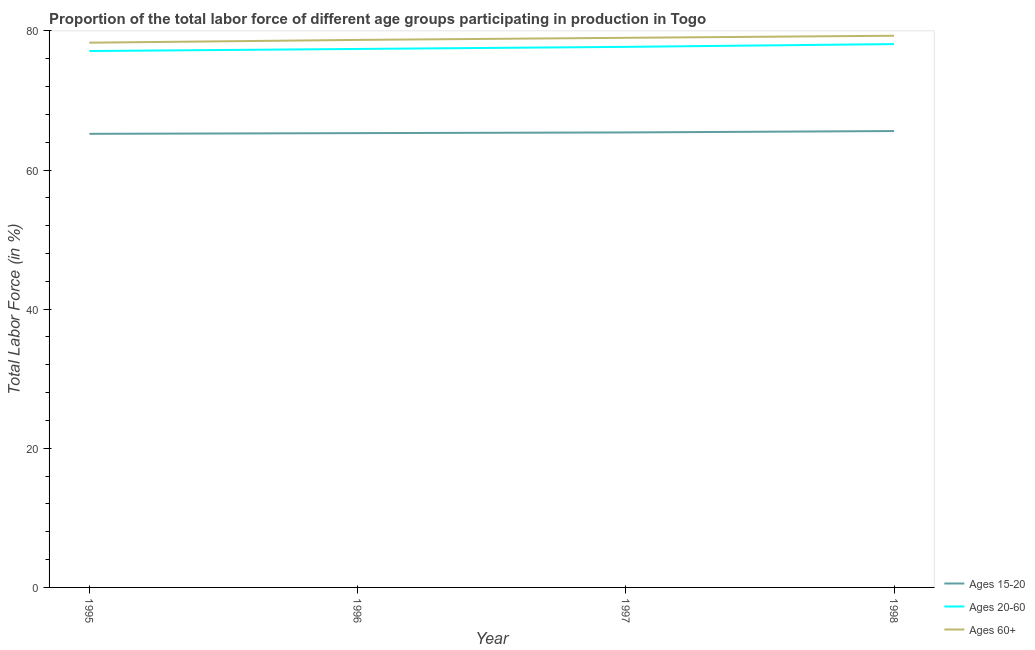Does the line corresponding to percentage of labor force within the age group 20-60 intersect with the line corresponding to percentage of labor force within the age group 15-20?
Your answer should be very brief. No. Is the number of lines equal to the number of legend labels?
Provide a short and direct response. Yes. What is the percentage of labor force within the age group 20-60 in 1998?
Make the answer very short. 78.1. Across all years, what is the maximum percentage of labor force above age 60?
Your answer should be very brief. 79.3. Across all years, what is the minimum percentage of labor force above age 60?
Your answer should be very brief. 78.3. In which year was the percentage of labor force above age 60 maximum?
Provide a short and direct response. 1998. In which year was the percentage of labor force within the age group 20-60 minimum?
Your response must be concise. 1995. What is the total percentage of labor force within the age group 20-60 in the graph?
Provide a succinct answer. 310.3. What is the difference between the percentage of labor force within the age group 15-20 in 1995 and that in 1996?
Ensure brevity in your answer.  -0.1. What is the difference between the percentage of labor force within the age group 15-20 in 1997 and the percentage of labor force within the age group 20-60 in 1998?
Ensure brevity in your answer.  -12.7. What is the average percentage of labor force within the age group 20-60 per year?
Your answer should be compact. 77.57. In the year 1996, what is the difference between the percentage of labor force above age 60 and percentage of labor force within the age group 15-20?
Your answer should be very brief. 13.4. What is the ratio of the percentage of labor force within the age group 20-60 in 1995 to that in 1998?
Your answer should be very brief. 0.99. What is the difference between the highest and the second highest percentage of labor force within the age group 20-60?
Your answer should be very brief. 0.4. What is the difference between the highest and the lowest percentage of labor force within the age group 20-60?
Offer a terse response. 1. Is it the case that in every year, the sum of the percentage of labor force within the age group 15-20 and percentage of labor force within the age group 20-60 is greater than the percentage of labor force above age 60?
Offer a very short reply. Yes. Does the percentage of labor force within the age group 20-60 monotonically increase over the years?
Provide a short and direct response. Yes. Is the percentage of labor force within the age group 15-20 strictly greater than the percentage of labor force above age 60 over the years?
Your response must be concise. No. Is the percentage of labor force within the age group 15-20 strictly less than the percentage of labor force within the age group 20-60 over the years?
Offer a terse response. Yes. How many lines are there?
Keep it short and to the point. 3. How many years are there in the graph?
Your response must be concise. 4. Are the values on the major ticks of Y-axis written in scientific E-notation?
Provide a succinct answer. No. Does the graph contain grids?
Your response must be concise. No. What is the title of the graph?
Your response must be concise. Proportion of the total labor force of different age groups participating in production in Togo. Does "Female employers" appear as one of the legend labels in the graph?
Provide a succinct answer. No. What is the label or title of the X-axis?
Your answer should be very brief. Year. What is the label or title of the Y-axis?
Provide a succinct answer. Total Labor Force (in %). What is the Total Labor Force (in %) of Ages 15-20 in 1995?
Make the answer very short. 65.2. What is the Total Labor Force (in %) of Ages 20-60 in 1995?
Make the answer very short. 77.1. What is the Total Labor Force (in %) of Ages 60+ in 1995?
Offer a terse response. 78.3. What is the Total Labor Force (in %) in Ages 15-20 in 1996?
Give a very brief answer. 65.3. What is the Total Labor Force (in %) of Ages 20-60 in 1996?
Keep it short and to the point. 77.4. What is the Total Labor Force (in %) in Ages 60+ in 1996?
Provide a succinct answer. 78.7. What is the Total Labor Force (in %) of Ages 15-20 in 1997?
Your answer should be compact. 65.4. What is the Total Labor Force (in %) in Ages 20-60 in 1997?
Ensure brevity in your answer.  77.7. What is the Total Labor Force (in %) of Ages 60+ in 1997?
Give a very brief answer. 79. What is the Total Labor Force (in %) in Ages 15-20 in 1998?
Your answer should be compact. 65.6. What is the Total Labor Force (in %) in Ages 20-60 in 1998?
Keep it short and to the point. 78.1. What is the Total Labor Force (in %) in Ages 60+ in 1998?
Offer a terse response. 79.3. Across all years, what is the maximum Total Labor Force (in %) in Ages 15-20?
Offer a very short reply. 65.6. Across all years, what is the maximum Total Labor Force (in %) of Ages 20-60?
Your response must be concise. 78.1. Across all years, what is the maximum Total Labor Force (in %) in Ages 60+?
Provide a short and direct response. 79.3. Across all years, what is the minimum Total Labor Force (in %) in Ages 15-20?
Keep it short and to the point. 65.2. Across all years, what is the minimum Total Labor Force (in %) in Ages 20-60?
Ensure brevity in your answer.  77.1. Across all years, what is the minimum Total Labor Force (in %) of Ages 60+?
Make the answer very short. 78.3. What is the total Total Labor Force (in %) in Ages 15-20 in the graph?
Make the answer very short. 261.5. What is the total Total Labor Force (in %) of Ages 20-60 in the graph?
Your answer should be very brief. 310.3. What is the total Total Labor Force (in %) in Ages 60+ in the graph?
Keep it short and to the point. 315.3. What is the difference between the Total Labor Force (in %) of Ages 15-20 in 1995 and that in 1996?
Offer a very short reply. -0.1. What is the difference between the Total Labor Force (in %) in Ages 60+ in 1995 and that in 1996?
Keep it short and to the point. -0.4. What is the difference between the Total Labor Force (in %) in Ages 15-20 in 1996 and that in 1997?
Provide a succinct answer. -0.1. What is the difference between the Total Labor Force (in %) in Ages 60+ in 1996 and that in 1997?
Provide a succinct answer. -0.3. What is the difference between the Total Labor Force (in %) in Ages 15-20 in 1996 and that in 1998?
Keep it short and to the point. -0.3. What is the difference between the Total Labor Force (in %) of Ages 60+ in 1996 and that in 1998?
Provide a succinct answer. -0.6. What is the difference between the Total Labor Force (in %) in Ages 15-20 in 1997 and that in 1998?
Your answer should be very brief. -0.2. What is the difference between the Total Labor Force (in %) in Ages 20-60 in 1997 and that in 1998?
Make the answer very short. -0.4. What is the difference between the Total Labor Force (in %) in Ages 60+ in 1997 and that in 1998?
Provide a succinct answer. -0.3. What is the difference between the Total Labor Force (in %) of Ages 15-20 in 1995 and the Total Labor Force (in %) of Ages 20-60 in 1996?
Make the answer very short. -12.2. What is the difference between the Total Labor Force (in %) of Ages 15-20 in 1995 and the Total Labor Force (in %) of Ages 60+ in 1996?
Your answer should be very brief. -13.5. What is the difference between the Total Labor Force (in %) of Ages 20-60 in 1995 and the Total Labor Force (in %) of Ages 60+ in 1996?
Your response must be concise. -1.6. What is the difference between the Total Labor Force (in %) of Ages 15-20 in 1995 and the Total Labor Force (in %) of Ages 60+ in 1997?
Provide a short and direct response. -13.8. What is the difference between the Total Labor Force (in %) in Ages 20-60 in 1995 and the Total Labor Force (in %) in Ages 60+ in 1997?
Your answer should be very brief. -1.9. What is the difference between the Total Labor Force (in %) in Ages 15-20 in 1995 and the Total Labor Force (in %) in Ages 60+ in 1998?
Offer a very short reply. -14.1. What is the difference between the Total Labor Force (in %) of Ages 20-60 in 1995 and the Total Labor Force (in %) of Ages 60+ in 1998?
Offer a very short reply. -2.2. What is the difference between the Total Labor Force (in %) of Ages 15-20 in 1996 and the Total Labor Force (in %) of Ages 60+ in 1997?
Offer a terse response. -13.7. What is the difference between the Total Labor Force (in %) of Ages 15-20 in 1996 and the Total Labor Force (in %) of Ages 60+ in 1998?
Offer a terse response. -14. What is the difference between the Total Labor Force (in %) of Ages 15-20 in 1997 and the Total Labor Force (in %) of Ages 20-60 in 1998?
Your response must be concise. -12.7. What is the difference between the Total Labor Force (in %) of Ages 15-20 in 1997 and the Total Labor Force (in %) of Ages 60+ in 1998?
Offer a very short reply. -13.9. What is the average Total Labor Force (in %) in Ages 15-20 per year?
Your answer should be compact. 65.38. What is the average Total Labor Force (in %) in Ages 20-60 per year?
Your response must be concise. 77.58. What is the average Total Labor Force (in %) in Ages 60+ per year?
Your answer should be compact. 78.83. In the year 1995, what is the difference between the Total Labor Force (in %) in Ages 15-20 and Total Labor Force (in %) in Ages 20-60?
Ensure brevity in your answer.  -11.9. In the year 1995, what is the difference between the Total Labor Force (in %) of Ages 15-20 and Total Labor Force (in %) of Ages 60+?
Provide a succinct answer. -13.1. In the year 1997, what is the difference between the Total Labor Force (in %) in Ages 15-20 and Total Labor Force (in %) in Ages 20-60?
Ensure brevity in your answer.  -12.3. In the year 1998, what is the difference between the Total Labor Force (in %) of Ages 15-20 and Total Labor Force (in %) of Ages 20-60?
Ensure brevity in your answer.  -12.5. In the year 1998, what is the difference between the Total Labor Force (in %) in Ages 15-20 and Total Labor Force (in %) in Ages 60+?
Offer a terse response. -13.7. What is the ratio of the Total Labor Force (in %) in Ages 20-60 in 1995 to that in 1996?
Provide a succinct answer. 1. What is the ratio of the Total Labor Force (in %) in Ages 15-20 in 1995 to that in 1997?
Ensure brevity in your answer.  1. What is the ratio of the Total Labor Force (in %) of Ages 20-60 in 1995 to that in 1997?
Ensure brevity in your answer.  0.99. What is the ratio of the Total Labor Force (in %) of Ages 20-60 in 1995 to that in 1998?
Ensure brevity in your answer.  0.99. What is the ratio of the Total Labor Force (in %) in Ages 60+ in 1995 to that in 1998?
Your answer should be compact. 0.99. What is the ratio of the Total Labor Force (in %) in Ages 20-60 in 1996 to that in 1997?
Your answer should be very brief. 1. What is the ratio of the Total Labor Force (in %) of Ages 60+ in 1996 to that in 1997?
Provide a short and direct response. 1. What is the ratio of the Total Labor Force (in %) in Ages 20-60 in 1996 to that in 1998?
Provide a short and direct response. 0.99. What is the ratio of the Total Labor Force (in %) of Ages 60+ in 1996 to that in 1998?
Give a very brief answer. 0.99. What is the ratio of the Total Labor Force (in %) of Ages 20-60 in 1997 to that in 1998?
Give a very brief answer. 0.99. What is the ratio of the Total Labor Force (in %) in Ages 60+ in 1997 to that in 1998?
Your answer should be compact. 1. What is the difference between the highest and the second highest Total Labor Force (in %) in Ages 60+?
Keep it short and to the point. 0.3. What is the difference between the highest and the lowest Total Labor Force (in %) of Ages 15-20?
Offer a very short reply. 0.4. 